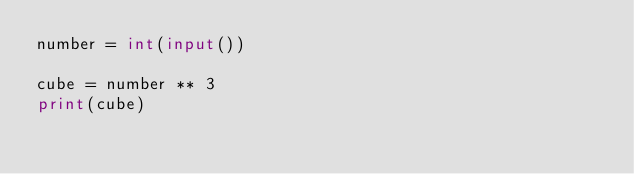Convert code to text. <code><loc_0><loc_0><loc_500><loc_500><_Python_>number = int(input())

cube = number ** 3
print(cube)
</code> 